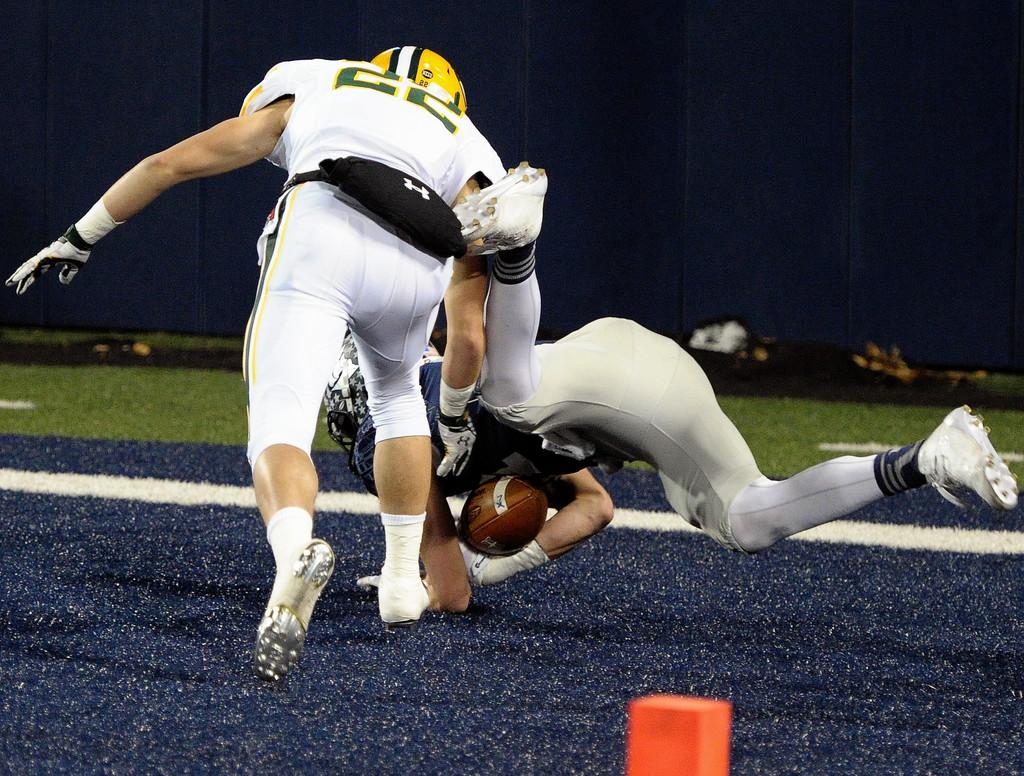What is happening in the center of the image? There are people in the center of the image, and they are playing. What can be seen in the background of the image? There is grassland and a curtain in the background of the image. Is there a fan visible in the image? There is no fan present in the image. Can you see any ghosts in the image? There are no ghosts present in the image. 